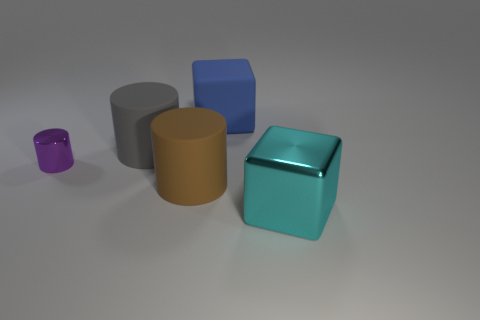What color is the thing that is the same material as the big cyan cube?
Keep it short and to the point. Purple. There is a metallic thing that is on the left side of the block that is left of the cyan shiny block; is there a tiny cylinder left of it?
Your answer should be very brief. No. What is the shape of the big blue object?
Ensure brevity in your answer.  Cube. Is the number of objects in front of the cyan shiny object less than the number of gray objects?
Keep it short and to the point. Yes. Is there a brown object that has the same shape as the big blue object?
Ensure brevity in your answer.  No. What shape is the brown rubber object that is the same size as the cyan object?
Your answer should be very brief. Cylinder. What number of objects are either blue objects or big matte cylinders?
Provide a short and direct response. 3. Are there any big purple rubber blocks?
Your answer should be compact. No. Are there fewer small brown cylinders than matte blocks?
Keep it short and to the point. Yes. Is there a purple metal cylinder that has the same size as the matte cube?
Your answer should be very brief. No. 